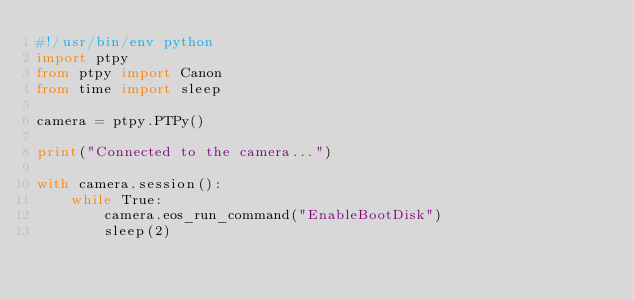<code> <loc_0><loc_0><loc_500><loc_500><_Python_>#!/usr/bin/env python
import ptpy
from ptpy import Canon
from time import sleep

camera = ptpy.PTPy()

print("Connected to the camera...")

with camera.session():
    while True:
        camera.eos_run_command("EnableBootDisk")
        sleep(2)</code> 